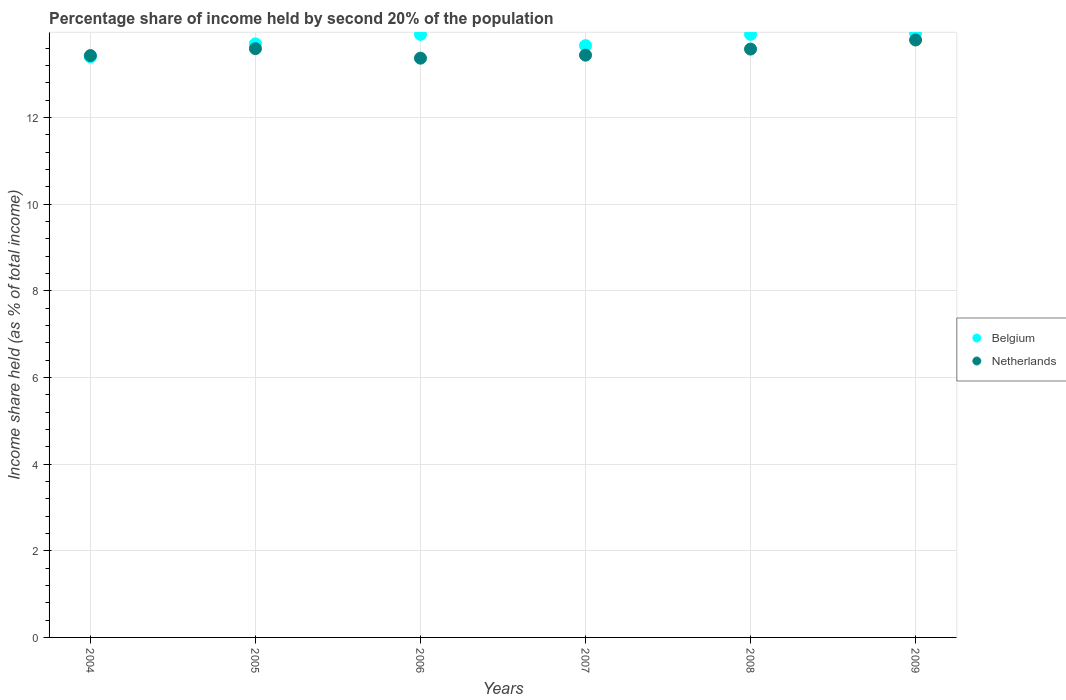What is the share of income held by second 20% of the population in Netherlands in 2008?
Provide a succinct answer. 13.58. Across all years, what is the maximum share of income held by second 20% of the population in Netherlands?
Give a very brief answer. 13.79. Across all years, what is the minimum share of income held by second 20% of the population in Belgium?
Give a very brief answer. 13.4. In which year was the share of income held by second 20% of the population in Netherlands maximum?
Provide a succinct answer. 2009. In which year was the share of income held by second 20% of the population in Netherlands minimum?
Offer a terse response. 2006. What is the total share of income held by second 20% of the population in Belgium in the graph?
Make the answer very short. 82.54. What is the difference between the share of income held by second 20% of the population in Belgium in 2005 and that in 2008?
Ensure brevity in your answer.  -0.22. What is the difference between the share of income held by second 20% of the population in Belgium in 2006 and the share of income held by second 20% of the population in Netherlands in 2009?
Your response must be concise. 0.13. What is the average share of income held by second 20% of the population in Netherlands per year?
Make the answer very short. 13.53. In the year 2004, what is the difference between the share of income held by second 20% of the population in Belgium and share of income held by second 20% of the population in Netherlands?
Make the answer very short. -0.03. What is the ratio of the share of income held by second 20% of the population in Belgium in 2004 to that in 2008?
Offer a very short reply. 0.96. Is the share of income held by second 20% of the population in Netherlands in 2005 less than that in 2008?
Keep it short and to the point. No. Is the difference between the share of income held by second 20% of the population in Belgium in 2005 and 2006 greater than the difference between the share of income held by second 20% of the population in Netherlands in 2005 and 2006?
Offer a terse response. No. What is the difference between the highest and the second highest share of income held by second 20% of the population in Belgium?
Provide a short and direct response. 0.02. What is the difference between the highest and the lowest share of income held by second 20% of the population in Belgium?
Your answer should be compact. 0.54. In how many years, is the share of income held by second 20% of the population in Netherlands greater than the average share of income held by second 20% of the population in Netherlands taken over all years?
Keep it short and to the point. 3. Is the share of income held by second 20% of the population in Belgium strictly greater than the share of income held by second 20% of the population in Netherlands over the years?
Provide a short and direct response. No. Is the share of income held by second 20% of the population in Belgium strictly less than the share of income held by second 20% of the population in Netherlands over the years?
Ensure brevity in your answer.  No. Does the graph contain any zero values?
Provide a short and direct response. No. Does the graph contain grids?
Provide a short and direct response. Yes. How many legend labels are there?
Offer a very short reply. 2. What is the title of the graph?
Your answer should be very brief. Percentage share of income held by second 20% of the population. Does "Virgin Islands" appear as one of the legend labels in the graph?
Your answer should be compact. No. What is the label or title of the X-axis?
Offer a very short reply. Years. What is the label or title of the Y-axis?
Provide a short and direct response. Income share held (as % of total income). What is the Income share held (as % of total income) of Netherlands in 2004?
Your answer should be compact. 13.43. What is the Income share held (as % of total income) of Belgium in 2005?
Offer a very short reply. 13.7. What is the Income share held (as % of total income) of Netherlands in 2005?
Make the answer very short. 13.59. What is the Income share held (as % of total income) of Belgium in 2006?
Give a very brief answer. 13.92. What is the Income share held (as % of total income) in Netherlands in 2006?
Make the answer very short. 13.37. What is the Income share held (as % of total income) in Belgium in 2007?
Give a very brief answer. 13.66. What is the Income share held (as % of total income) of Netherlands in 2007?
Make the answer very short. 13.44. What is the Income share held (as % of total income) of Belgium in 2008?
Make the answer very short. 13.92. What is the Income share held (as % of total income) of Netherlands in 2008?
Offer a very short reply. 13.58. What is the Income share held (as % of total income) of Belgium in 2009?
Provide a short and direct response. 13.94. What is the Income share held (as % of total income) in Netherlands in 2009?
Provide a short and direct response. 13.79. Across all years, what is the maximum Income share held (as % of total income) of Belgium?
Your response must be concise. 13.94. Across all years, what is the maximum Income share held (as % of total income) in Netherlands?
Ensure brevity in your answer.  13.79. Across all years, what is the minimum Income share held (as % of total income) of Belgium?
Provide a succinct answer. 13.4. Across all years, what is the minimum Income share held (as % of total income) of Netherlands?
Your answer should be compact. 13.37. What is the total Income share held (as % of total income) of Belgium in the graph?
Make the answer very short. 82.54. What is the total Income share held (as % of total income) in Netherlands in the graph?
Your response must be concise. 81.2. What is the difference between the Income share held (as % of total income) in Belgium in 2004 and that in 2005?
Ensure brevity in your answer.  -0.3. What is the difference between the Income share held (as % of total income) of Netherlands in 2004 and that in 2005?
Keep it short and to the point. -0.16. What is the difference between the Income share held (as % of total income) in Belgium in 2004 and that in 2006?
Your answer should be compact. -0.52. What is the difference between the Income share held (as % of total income) of Belgium in 2004 and that in 2007?
Give a very brief answer. -0.26. What is the difference between the Income share held (as % of total income) of Netherlands in 2004 and that in 2007?
Your answer should be very brief. -0.01. What is the difference between the Income share held (as % of total income) in Belgium in 2004 and that in 2008?
Give a very brief answer. -0.52. What is the difference between the Income share held (as % of total income) of Belgium in 2004 and that in 2009?
Your answer should be very brief. -0.54. What is the difference between the Income share held (as % of total income) in Netherlands in 2004 and that in 2009?
Provide a short and direct response. -0.36. What is the difference between the Income share held (as % of total income) of Belgium in 2005 and that in 2006?
Your answer should be compact. -0.22. What is the difference between the Income share held (as % of total income) in Netherlands in 2005 and that in 2006?
Make the answer very short. 0.22. What is the difference between the Income share held (as % of total income) of Belgium in 2005 and that in 2007?
Your answer should be very brief. 0.04. What is the difference between the Income share held (as % of total income) of Belgium in 2005 and that in 2008?
Your response must be concise. -0.22. What is the difference between the Income share held (as % of total income) of Belgium in 2005 and that in 2009?
Keep it short and to the point. -0.24. What is the difference between the Income share held (as % of total income) of Netherlands in 2005 and that in 2009?
Your answer should be very brief. -0.2. What is the difference between the Income share held (as % of total income) of Belgium in 2006 and that in 2007?
Make the answer very short. 0.26. What is the difference between the Income share held (as % of total income) in Netherlands in 2006 and that in 2007?
Provide a short and direct response. -0.07. What is the difference between the Income share held (as % of total income) of Netherlands in 2006 and that in 2008?
Ensure brevity in your answer.  -0.21. What is the difference between the Income share held (as % of total income) in Belgium in 2006 and that in 2009?
Your answer should be compact. -0.02. What is the difference between the Income share held (as % of total income) in Netherlands in 2006 and that in 2009?
Provide a succinct answer. -0.42. What is the difference between the Income share held (as % of total income) of Belgium in 2007 and that in 2008?
Provide a short and direct response. -0.26. What is the difference between the Income share held (as % of total income) of Netherlands in 2007 and that in 2008?
Give a very brief answer. -0.14. What is the difference between the Income share held (as % of total income) of Belgium in 2007 and that in 2009?
Provide a short and direct response. -0.28. What is the difference between the Income share held (as % of total income) in Netherlands in 2007 and that in 2009?
Make the answer very short. -0.35. What is the difference between the Income share held (as % of total income) of Belgium in 2008 and that in 2009?
Ensure brevity in your answer.  -0.02. What is the difference between the Income share held (as % of total income) of Netherlands in 2008 and that in 2009?
Ensure brevity in your answer.  -0.21. What is the difference between the Income share held (as % of total income) of Belgium in 2004 and the Income share held (as % of total income) of Netherlands in 2005?
Offer a very short reply. -0.19. What is the difference between the Income share held (as % of total income) of Belgium in 2004 and the Income share held (as % of total income) of Netherlands in 2007?
Provide a succinct answer. -0.04. What is the difference between the Income share held (as % of total income) in Belgium in 2004 and the Income share held (as % of total income) in Netherlands in 2008?
Offer a terse response. -0.18. What is the difference between the Income share held (as % of total income) in Belgium in 2004 and the Income share held (as % of total income) in Netherlands in 2009?
Your answer should be compact. -0.39. What is the difference between the Income share held (as % of total income) of Belgium in 2005 and the Income share held (as % of total income) of Netherlands in 2006?
Offer a terse response. 0.33. What is the difference between the Income share held (as % of total income) in Belgium in 2005 and the Income share held (as % of total income) in Netherlands in 2007?
Offer a terse response. 0.26. What is the difference between the Income share held (as % of total income) of Belgium in 2005 and the Income share held (as % of total income) of Netherlands in 2008?
Offer a very short reply. 0.12. What is the difference between the Income share held (as % of total income) in Belgium in 2005 and the Income share held (as % of total income) in Netherlands in 2009?
Make the answer very short. -0.09. What is the difference between the Income share held (as % of total income) of Belgium in 2006 and the Income share held (as % of total income) of Netherlands in 2007?
Your answer should be very brief. 0.48. What is the difference between the Income share held (as % of total income) in Belgium in 2006 and the Income share held (as % of total income) in Netherlands in 2008?
Make the answer very short. 0.34. What is the difference between the Income share held (as % of total income) of Belgium in 2006 and the Income share held (as % of total income) of Netherlands in 2009?
Give a very brief answer. 0.13. What is the difference between the Income share held (as % of total income) of Belgium in 2007 and the Income share held (as % of total income) of Netherlands in 2009?
Make the answer very short. -0.13. What is the difference between the Income share held (as % of total income) in Belgium in 2008 and the Income share held (as % of total income) in Netherlands in 2009?
Provide a short and direct response. 0.13. What is the average Income share held (as % of total income) of Belgium per year?
Provide a succinct answer. 13.76. What is the average Income share held (as % of total income) in Netherlands per year?
Offer a very short reply. 13.53. In the year 2004, what is the difference between the Income share held (as % of total income) of Belgium and Income share held (as % of total income) of Netherlands?
Your answer should be very brief. -0.03. In the year 2005, what is the difference between the Income share held (as % of total income) in Belgium and Income share held (as % of total income) in Netherlands?
Keep it short and to the point. 0.11. In the year 2006, what is the difference between the Income share held (as % of total income) of Belgium and Income share held (as % of total income) of Netherlands?
Make the answer very short. 0.55. In the year 2007, what is the difference between the Income share held (as % of total income) of Belgium and Income share held (as % of total income) of Netherlands?
Your response must be concise. 0.22. In the year 2008, what is the difference between the Income share held (as % of total income) of Belgium and Income share held (as % of total income) of Netherlands?
Your response must be concise. 0.34. In the year 2009, what is the difference between the Income share held (as % of total income) of Belgium and Income share held (as % of total income) of Netherlands?
Ensure brevity in your answer.  0.15. What is the ratio of the Income share held (as % of total income) of Belgium in 2004 to that in 2005?
Ensure brevity in your answer.  0.98. What is the ratio of the Income share held (as % of total income) of Belgium in 2004 to that in 2006?
Keep it short and to the point. 0.96. What is the ratio of the Income share held (as % of total income) in Netherlands in 2004 to that in 2006?
Your answer should be very brief. 1. What is the ratio of the Income share held (as % of total income) in Netherlands in 2004 to that in 2007?
Give a very brief answer. 1. What is the ratio of the Income share held (as % of total income) of Belgium in 2004 to that in 2008?
Make the answer very short. 0.96. What is the ratio of the Income share held (as % of total income) in Belgium in 2004 to that in 2009?
Your answer should be compact. 0.96. What is the ratio of the Income share held (as % of total income) in Netherlands in 2004 to that in 2009?
Provide a succinct answer. 0.97. What is the ratio of the Income share held (as % of total income) in Belgium in 2005 to that in 2006?
Provide a short and direct response. 0.98. What is the ratio of the Income share held (as % of total income) in Netherlands in 2005 to that in 2006?
Provide a short and direct response. 1.02. What is the ratio of the Income share held (as % of total income) in Belgium in 2005 to that in 2007?
Offer a very short reply. 1. What is the ratio of the Income share held (as % of total income) of Netherlands in 2005 to that in 2007?
Keep it short and to the point. 1.01. What is the ratio of the Income share held (as % of total income) in Belgium in 2005 to that in 2008?
Keep it short and to the point. 0.98. What is the ratio of the Income share held (as % of total income) in Netherlands in 2005 to that in 2008?
Provide a short and direct response. 1. What is the ratio of the Income share held (as % of total income) of Belgium in 2005 to that in 2009?
Offer a terse response. 0.98. What is the ratio of the Income share held (as % of total income) of Netherlands in 2005 to that in 2009?
Ensure brevity in your answer.  0.99. What is the ratio of the Income share held (as % of total income) of Netherlands in 2006 to that in 2007?
Ensure brevity in your answer.  0.99. What is the ratio of the Income share held (as % of total income) of Belgium in 2006 to that in 2008?
Offer a terse response. 1. What is the ratio of the Income share held (as % of total income) in Netherlands in 2006 to that in 2008?
Your answer should be very brief. 0.98. What is the ratio of the Income share held (as % of total income) of Belgium in 2006 to that in 2009?
Offer a very short reply. 1. What is the ratio of the Income share held (as % of total income) of Netherlands in 2006 to that in 2009?
Your response must be concise. 0.97. What is the ratio of the Income share held (as % of total income) in Belgium in 2007 to that in 2008?
Offer a very short reply. 0.98. What is the ratio of the Income share held (as % of total income) in Belgium in 2007 to that in 2009?
Keep it short and to the point. 0.98. What is the ratio of the Income share held (as % of total income) in Netherlands in 2007 to that in 2009?
Your answer should be very brief. 0.97. What is the ratio of the Income share held (as % of total income) in Belgium in 2008 to that in 2009?
Your response must be concise. 1. What is the ratio of the Income share held (as % of total income) of Netherlands in 2008 to that in 2009?
Offer a terse response. 0.98. What is the difference between the highest and the lowest Income share held (as % of total income) of Belgium?
Give a very brief answer. 0.54. What is the difference between the highest and the lowest Income share held (as % of total income) in Netherlands?
Your answer should be compact. 0.42. 